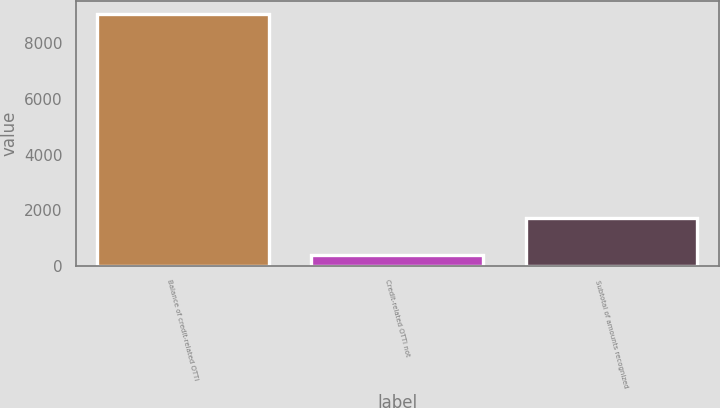Convert chart to OTSL. <chart><loc_0><loc_0><loc_500><loc_500><bar_chart><fcel>Balance of credit-related OTTI<fcel>Credit-related OTTI not<fcel>Subtotal of amounts recognized<nl><fcel>9052<fcel>403<fcel>1717.6<nl></chart> 